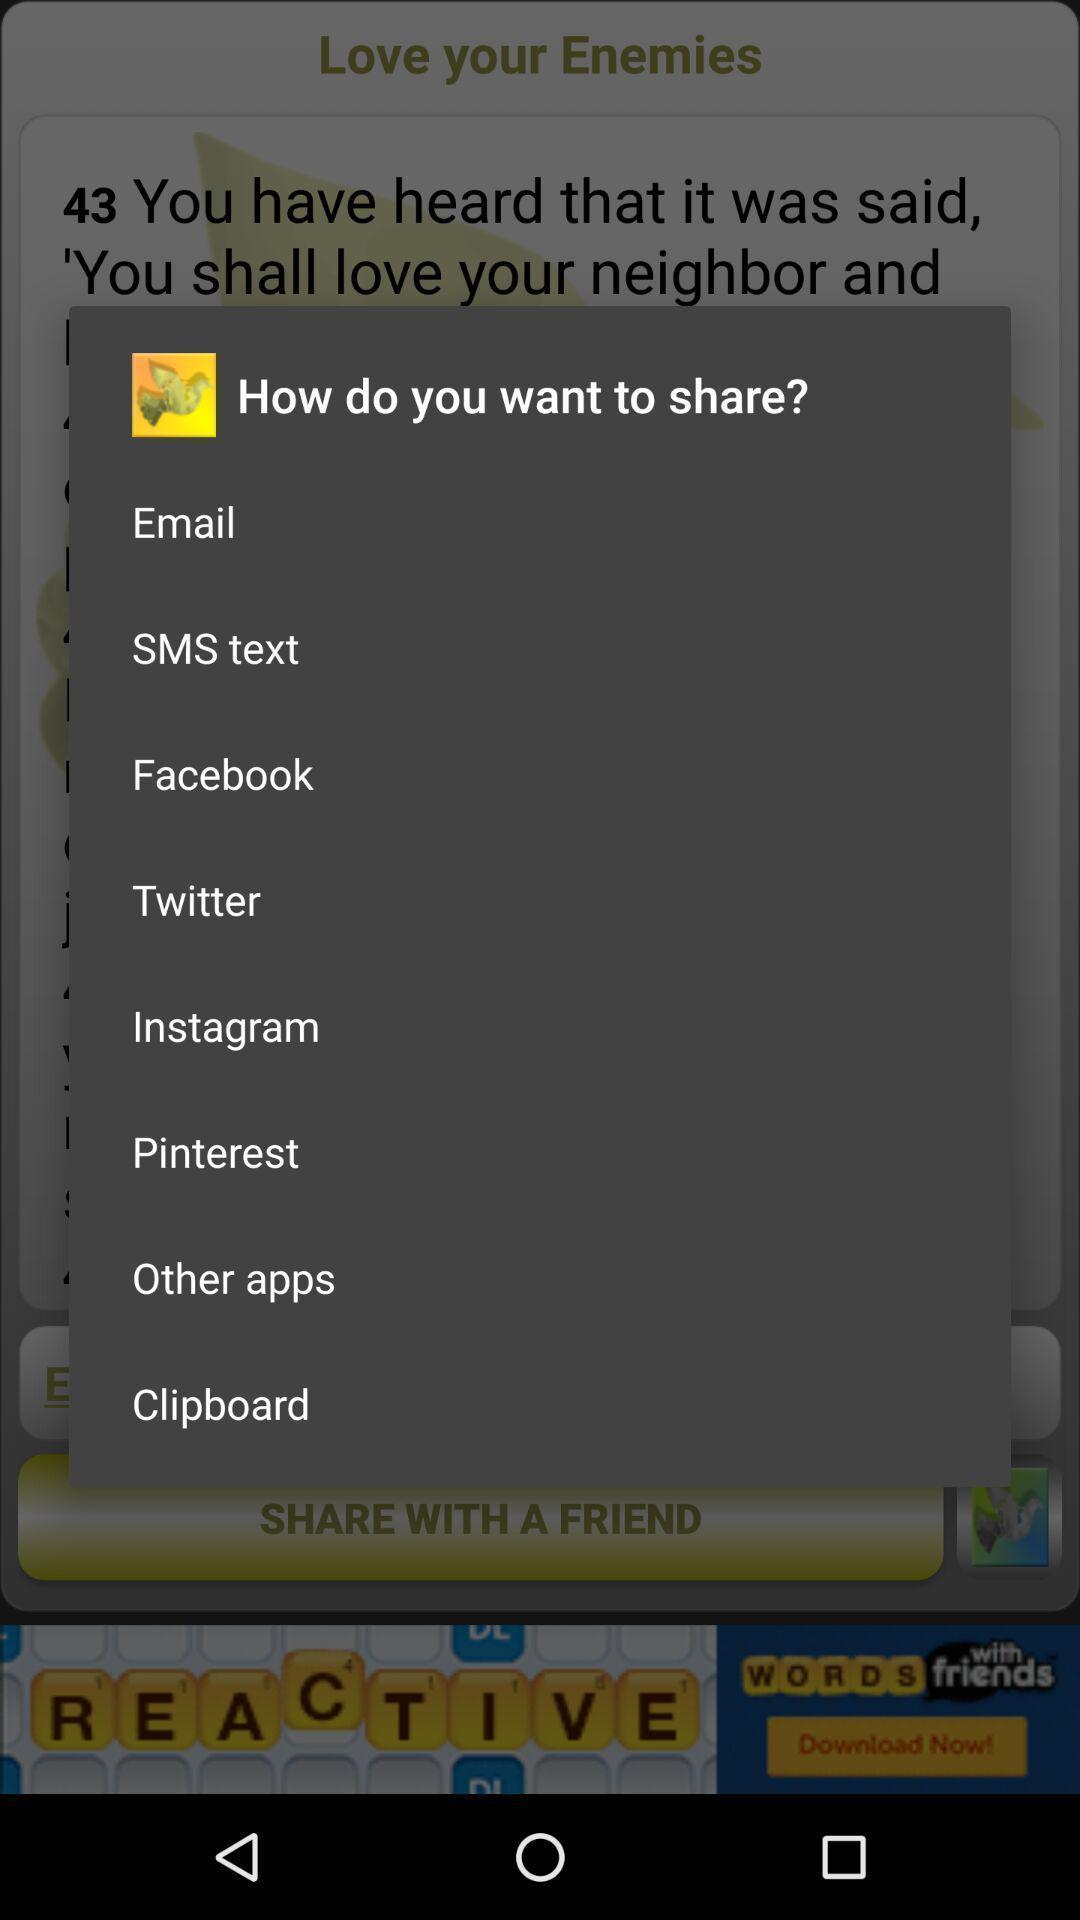What can you discern from this picture? Pop-up displaying options to share. 